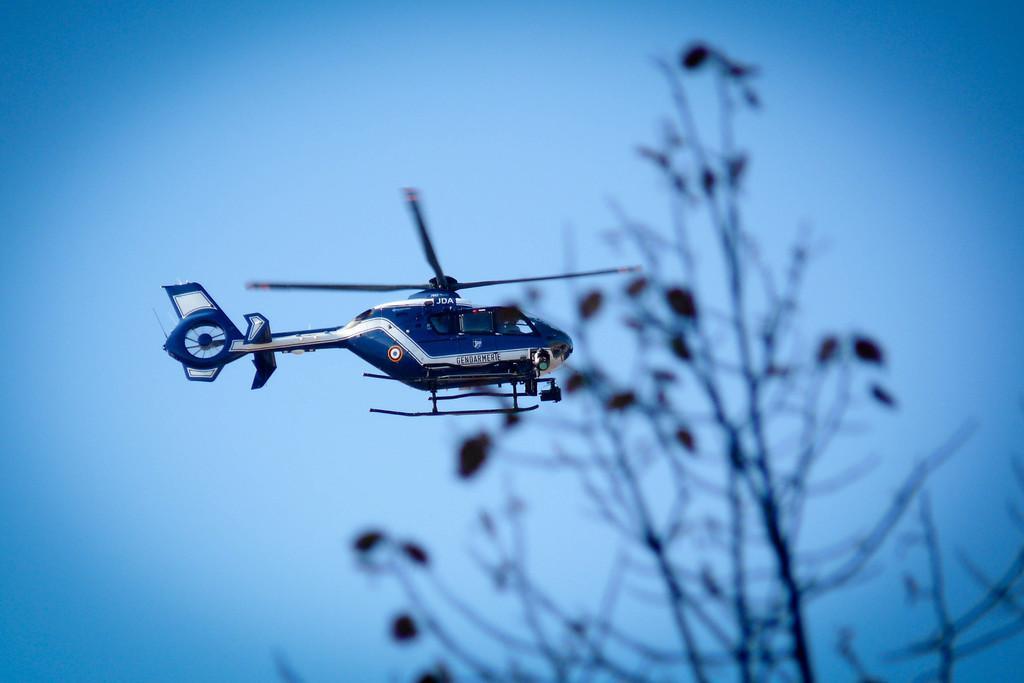In one or two sentences, can you explain what this image depicts? In this image we can see there is a helicopter flying in the air, beside that there is a tree. 